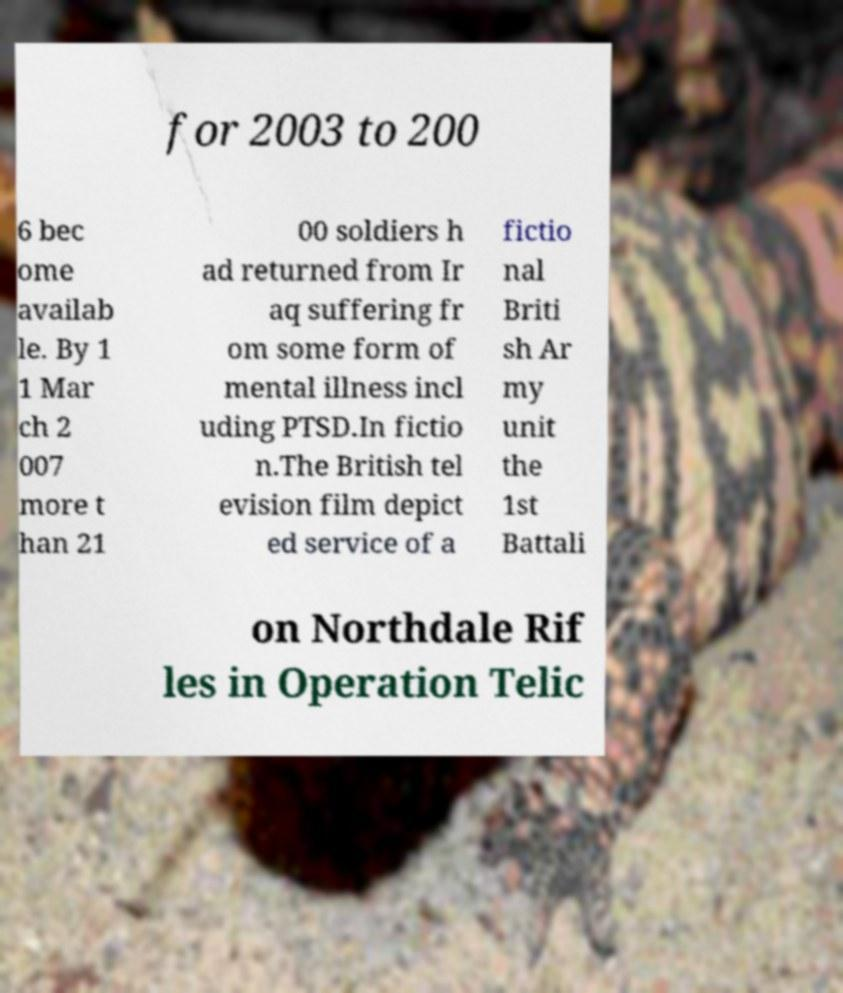Can you accurately transcribe the text from the provided image for me? for 2003 to 200 6 bec ome availab le. By 1 1 Mar ch 2 007 more t han 21 00 soldiers h ad returned from Ir aq suffering fr om some form of mental illness incl uding PTSD.In fictio n.The British tel evision film depict ed service of a fictio nal Briti sh Ar my unit the 1st Battali on Northdale Rif les in Operation Telic 